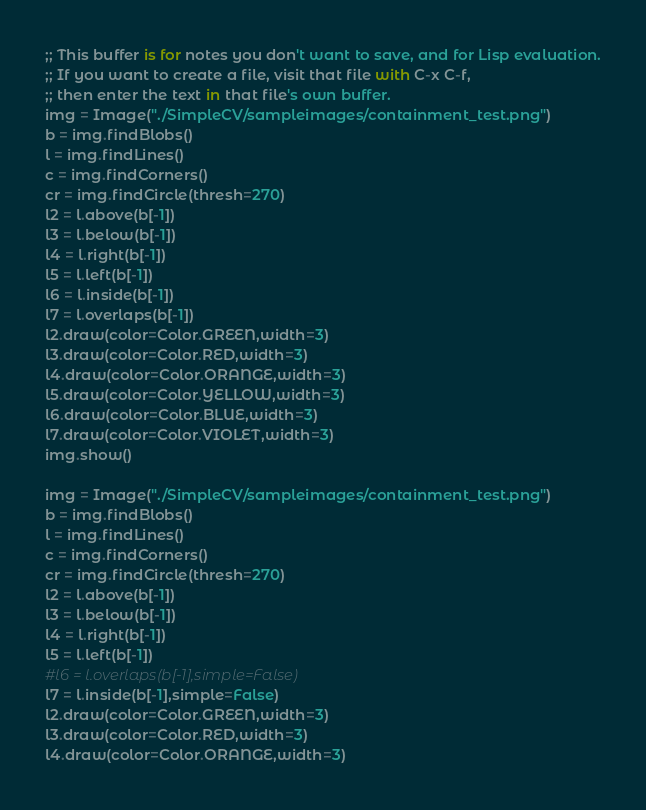Convert code to text. <code><loc_0><loc_0><loc_500><loc_500><_Python_>;; This buffer is for notes you don't want to save, and for Lisp evaluation.
;; If you want to create a file, visit that file with C-x C-f,
;; then enter the text in that file's own buffer.
img = Image("./SimpleCV/sampleimages/containment_test.png")
b = img.findBlobs()
l = img.findLines()
c = img.findCorners()
cr = img.findCircle(thresh=270)
l2 = l.above(b[-1])
l3 = l.below(b[-1])
l4 = l.right(b[-1])
l5 = l.left(b[-1])
l6 = l.inside(b[-1])
l7 = l.overlaps(b[-1])
l2.draw(color=Color.GREEN,width=3)
l3.draw(color=Color.RED,width=3)
l4.draw(color=Color.ORANGE,width=3)
l5.draw(color=Color.YELLOW,width=3)
l6.draw(color=Color.BLUE,width=3)
l7.draw(color=Color.VIOLET,width=3)
img.show()

img = Image("./SimpleCV/sampleimages/containment_test.png")
b = img.findBlobs()
l = img.findLines()
c = img.findCorners()
cr = img.findCircle(thresh=270)
l2 = l.above(b[-1])
l3 = l.below(b[-1])
l4 = l.right(b[-1])
l5 = l.left(b[-1])
#l6 = l.overlaps(b[-1],simple=False)
l7 = l.inside(b[-1],simple=False)
l2.draw(color=Color.GREEN,width=3)
l3.draw(color=Color.RED,width=3)
l4.draw(color=Color.ORANGE,width=3)</code> 